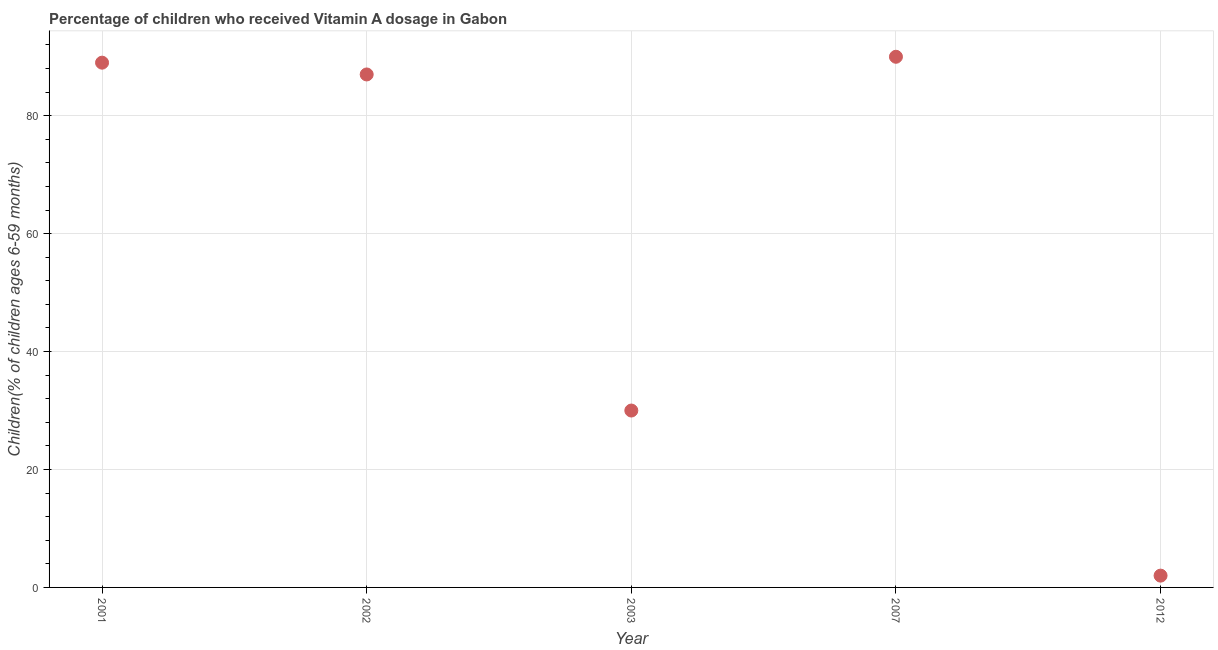What is the vitamin a supplementation coverage rate in 2012?
Your answer should be very brief. 2. Across all years, what is the maximum vitamin a supplementation coverage rate?
Offer a terse response. 90. Across all years, what is the minimum vitamin a supplementation coverage rate?
Ensure brevity in your answer.  2. In which year was the vitamin a supplementation coverage rate maximum?
Provide a short and direct response. 2007. What is the sum of the vitamin a supplementation coverage rate?
Provide a succinct answer. 298. What is the difference between the vitamin a supplementation coverage rate in 2001 and 2003?
Provide a short and direct response. 59. What is the average vitamin a supplementation coverage rate per year?
Your answer should be very brief. 59.6. In how many years, is the vitamin a supplementation coverage rate greater than 64 %?
Ensure brevity in your answer.  3. Do a majority of the years between 2012 and 2002 (inclusive) have vitamin a supplementation coverage rate greater than 56 %?
Keep it short and to the point. Yes. What is the ratio of the vitamin a supplementation coverage rate in 2003 to that in 2007?
Your response must be concise. 0.33. Is the vitamin a supplementation coverage rate in 2002 less than that in 2003?
Provide a short and direct response. No. Is the difference between the vitamin a supplementation coverage rate in 2002 and 2003 greater than the difference between any two years?
Provide a succinct answer. No. What is the difference between the highest and the second highest vitamin a supplementation coverage rate?
Provide a short and direct response. 1. Is the sum of the vitamin a supplementation coverage rate in 2001 and 2002 greater than the maximum vitamin a supplementation coverage rate across all years?
Offer a very short reply. Yes. What is the difference between the highest and the lowest vitamin a supplementation coverage rate?
Offer a very short reply. 88. How many dotlines are there?
Ensure brevity in your answer.  1. How many years are there in the graph?
Your answer should be compact. 5. What is the difference between two consecutive major ticks on the Y-axis?
Offer a very short reply. 20. Does the graph contain grids?
Ensure brevity in your answer.  Yes. What is the title of the graph?
Your answer should be compact. Percentage of children who received Vitamin A dosage in Gabon. What is the label or title of the Y-axis?
Keep it short and to the point. Children(% of children ages 6-59 months). What is the Children(% of children ages 6-59 months) in 2001?
Keep it short and to the point. 89. What is the Children(% of children ages 6-59 months) in 2002?
Make the answer very short. 87. What is the Children(% of children ages 6-59 months) in 2003?
Ensure brevity in your answer.  30. What is the Children(% of children ages 6-59 months) in 2012?
Provide a short and direct response. 2. What is the difference between the Children(% of children ages 6-59 months) in 2001 and 2003?
Make the answer very short. 59. What is the difference between the Children(% of children ages 6-59 months) in 2002 and 2003?
Your answer should be very brief. 57. What is the difference between the Children(% of children ages 6-59 months) in 2003 and 2007?
Offer a very short reply. -60. What is the ratio of the Children(% of children ages 6-59 months) in 2001 to that in 2002?
Offer a terse response. 1.02. What is the ratio of the Children(% of children ages 6-59 months) in 2001 to that in 2003?
Your response must be concise. 2.97. What is the ratio of the Children(% of children ages 6-59 months) in 2001 to that in 2012?
Make the answer very short. 44.5. What is the ratio of the Children(% of children ages 6-59 months) in 2002 to that in 2007?
Your response must be concise. 0.97. What is the ratio of the Children(% of children ages 6-59 months) in 2002 to that in 2012?
Offer a terse response. 43.5. What is the ratio of the Children(% of children ages 6-59 months) in 2003 to that in 2007?
Ensure brevity in your answer.  0.33. What is the ratio of the Children(% of children ages 6-59 months) in 2003 to that in 2012?
Offer a very short reply. 15. What is the ratio of the Children(% of children ages 6-59 months) in 2007 to that in 2012?
Keep it short and to the point. 45. 